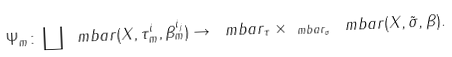Convert formula to latex. <formula><loc_0><loc_0><loc_500><loc_500>\Psi _ { m } \colon \coprod \ m b a r ( X , \tau _ { m } ^ { i } , \beta _ { m } ^ { i _ { j } } ) \to \ m b a r _ { \tau } \times _ { \ m b a r _ { \sigma } } \ m b a r ( X , \tilde { \sigma } , \beta ) .</formula> 